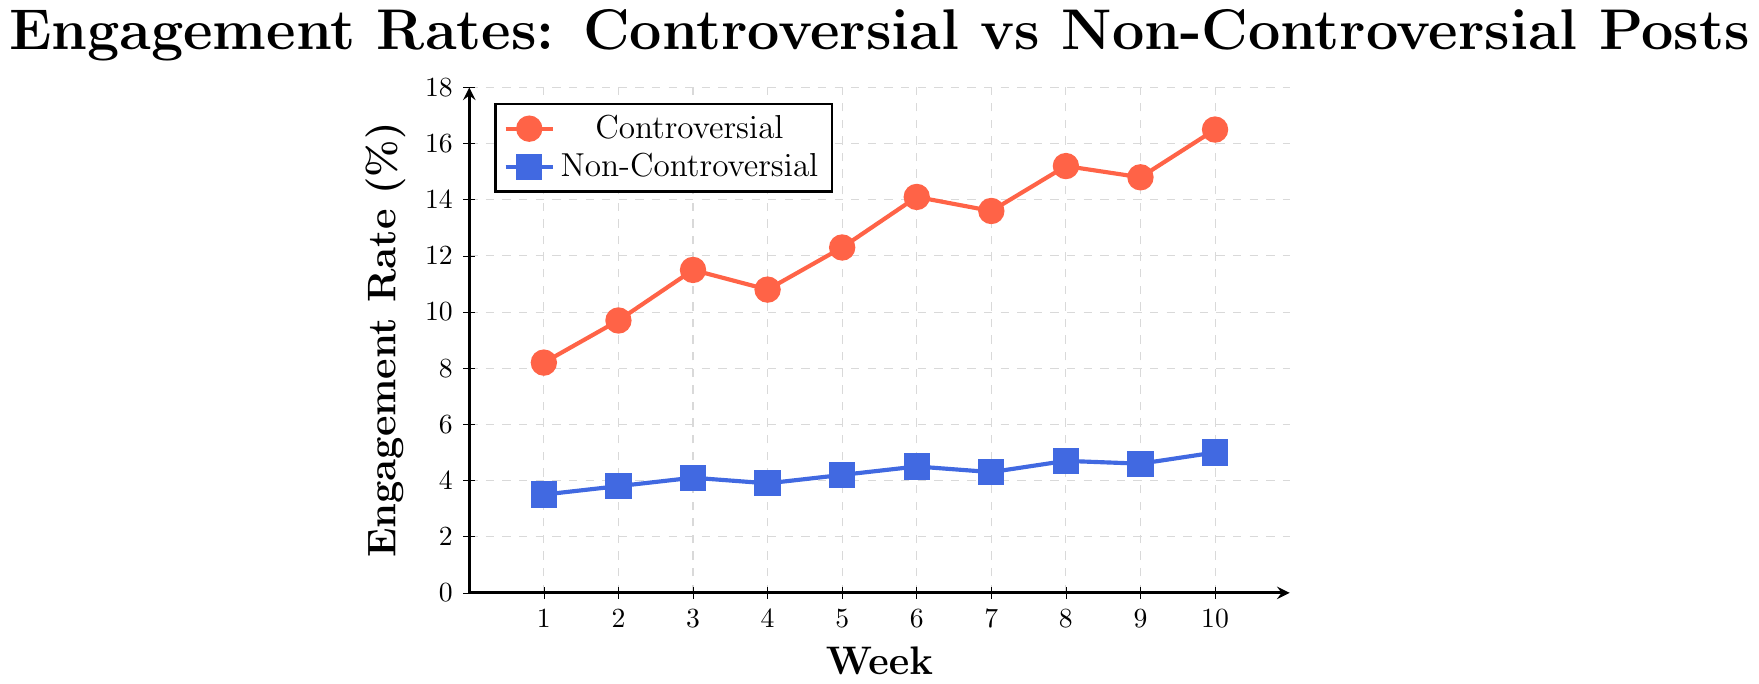What's the engagement rate for controversial posts in week 5? Look at the line chart or the data for the controversial posts and specifically for week 5, then find the corresponding engagement rate
Answer: 12.3 What's the difference in engagement rates between controversial and non-controversial posts in week 7? Find the engagement rate for controversial posts in week 7 (13.6) and for non-controversial posts in week 7 (4.3). Subtract the engagement rate of non-controversial posts from that of controversial posts
Answer: 9.3 What is the overall trend in engagement rates for controversial posts over the 10-week period? Observe the engagement rates for controversial posts from weeks 1 to 10. Notice that the values generally increase, with minor fluctuations, indicating an overall increasing trend
Answer: Increasing trend In which week do controversial posts have the highest engagement rate, and what is that rate? Look at the line representing controversial posts and identify the highest point, which occurs in week 10 with an engagement rate of 16.5%
Answer: Week 10, 16.5% How does the engagement rate for non-controversial posts change from week 1 to week 10? Identify the engagement rates for non-controversial posts in weeks 1 and 10 (3.5% and 5.0% respectively). The rate shows a slight increase over the 10-week period
Answer: Slight increase Compare the engagement rate of non-controversial posts in week 6 and week 8. Which week has a higher rate and by how much? Find the engagement rates for non-controversial posts in weeks 6 (4.5%) and 8 (4.7%). Compare the two values and calculate the difference (4.7 - 4.5)
Answer: Week 8, by 0.2% What’s the average engagement rate for non-controversial posts across the 10-week period? Sum the engagement rates for non-controversial posts over the 10 weeks (3.5 + 3.8 + 4.1 + 3.9 + 4.2 + 4.5 + 4.3 + 4.7 + 4.6 + 5.0 = 42.6) and divide by the number of weeks (10)
Answer: 4.26% During which weeks do non-controversial posts have an engagement rate of exactly 4.1%? Check the engagement rates for non-controversial posts in each week and find the weeks where the rate is 4.1%. This occurs in week 3
Answer: Week 3 How does the engagement rate of controversial posts compare to non-controversial posts in week 2? Look at the engagement rates for controversial (9.7%) and non-controversial (3.8%) posts in week 2. The engagement rate for controversial posts is significantly higher
Answer: Controversial posts are significantly higher What’s the combined average engagement rate for both controversial and non-controversial posts over 10 weeks? Find the sum of all engagement rates (controversial: 126.7 and non-controversial: 42.6), total is 169.3. Divide by the number of weeks (10), average engagement rate = 169.3 / 10
Answer: 16.93% 